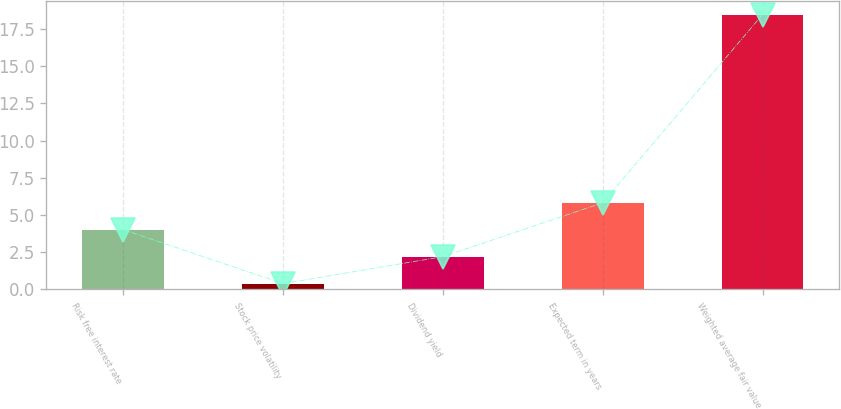Convert chart. <chart><loc_0><loc_0><loc_500><loc_500><bar_chart><fcel>Risk free interest rate<fcel>Stock price volatility<fcel>Dividend yield<fcel>Expected term in years<fcel>Weighted average fair value<nl><fcel>4.01<fcel>0.39<fcel>2.2<fcel>5.82<fcel>18.47<nl></chart> 